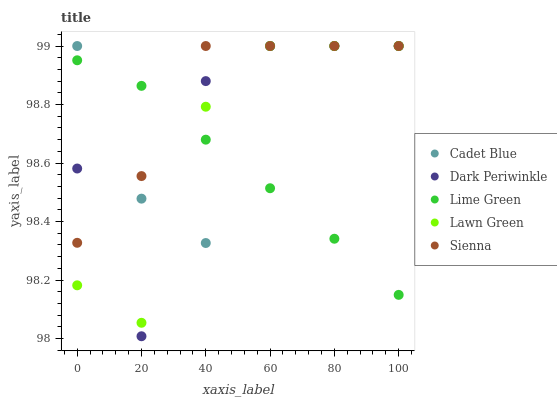Does Lime Green have the minimum area under the curve?
Answer yes or no. Yes. Does Sienna have the maximum area under the curve?
Answer yes or no. Yes. Does Lawn Green have the minimum area under the curve?
Answer yes or no. No. Does Lawn Green have the maximum area under the curve?
Answer yes or no. No. Is Lime Green the smoothest?
Answer yes or no. Yes. Is Dark Periwinkle the roughest?
Answer yes or no. Yes. Is Lawn Green the smoothest?
Answer yes or no. No. Is Lawn Green the roughest?
Answer yes or no. No. Does Dark Periwinkle have the lowest value?
Answer yes or no. Yes. Does Lawn Green have the lowest value?
Answer yes or no. No. Does Dark Periwinkle have the highest value?
Answer yes or no. Yes. Does Lime Green have the highest value?
Answer yes or no. No. Does Lime Green intersect Lawn Green?
Answer yes or no. Yes. Is Lime Green less than Lawn Green?
Answer yes or no. No. Is Lime Green greater than Lawn Green?
Answer yes or no. No. 